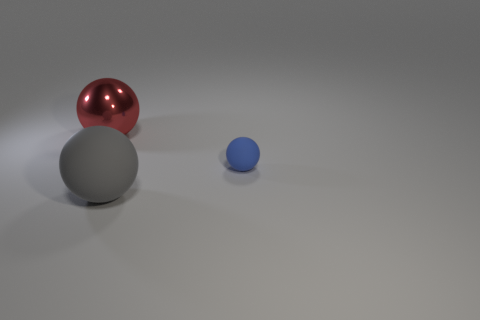Does the large object that is in front of the blue sphere have the same material as the object that is behind the blue object?
Offer a terse response. No. Are there fewer big gray spheres than big brown rubber cylinders?
Give a very brief answer. No. There is a object behind the tiny blue object; are there any gray rubber objects that are on the right side of it?
Provide a succinct answer. Yes. There is a object that is in front of the rubber object behind the gray matte ball; are there any spheres that are behind it?
Make the answer very short. Yes. There is a object that is made of the same material as the tiny ball; what color is it?
Ensure brevity in your answer.  Gray. Are there fewer big shiny balls on the left side of the red object than big brown shiny balls?
Keep it short and to the point. No. There is a matte thing on the right side of the big thing that is in front of the thing that is behind the tiny blue matte object; how big is it?
Offer a terse response. Small. Do the big ball that is on the right side of the metallic thing and the small ball have the same material?
Keep it short and to the point. Yes. Are there any other things that have the same shape as the metallic thing?
Provide a succinct answer. Yes. How many objects are either big red things or tiny green things?
Your response must be concise. 1. 